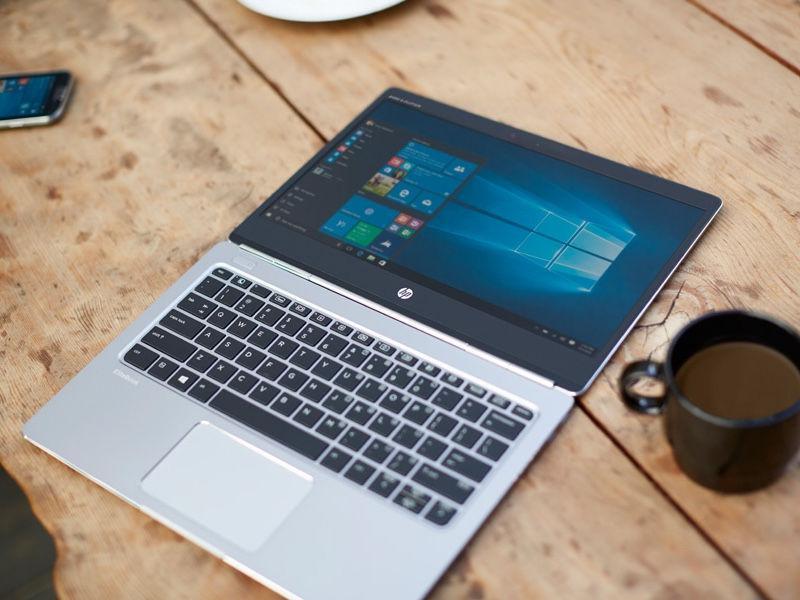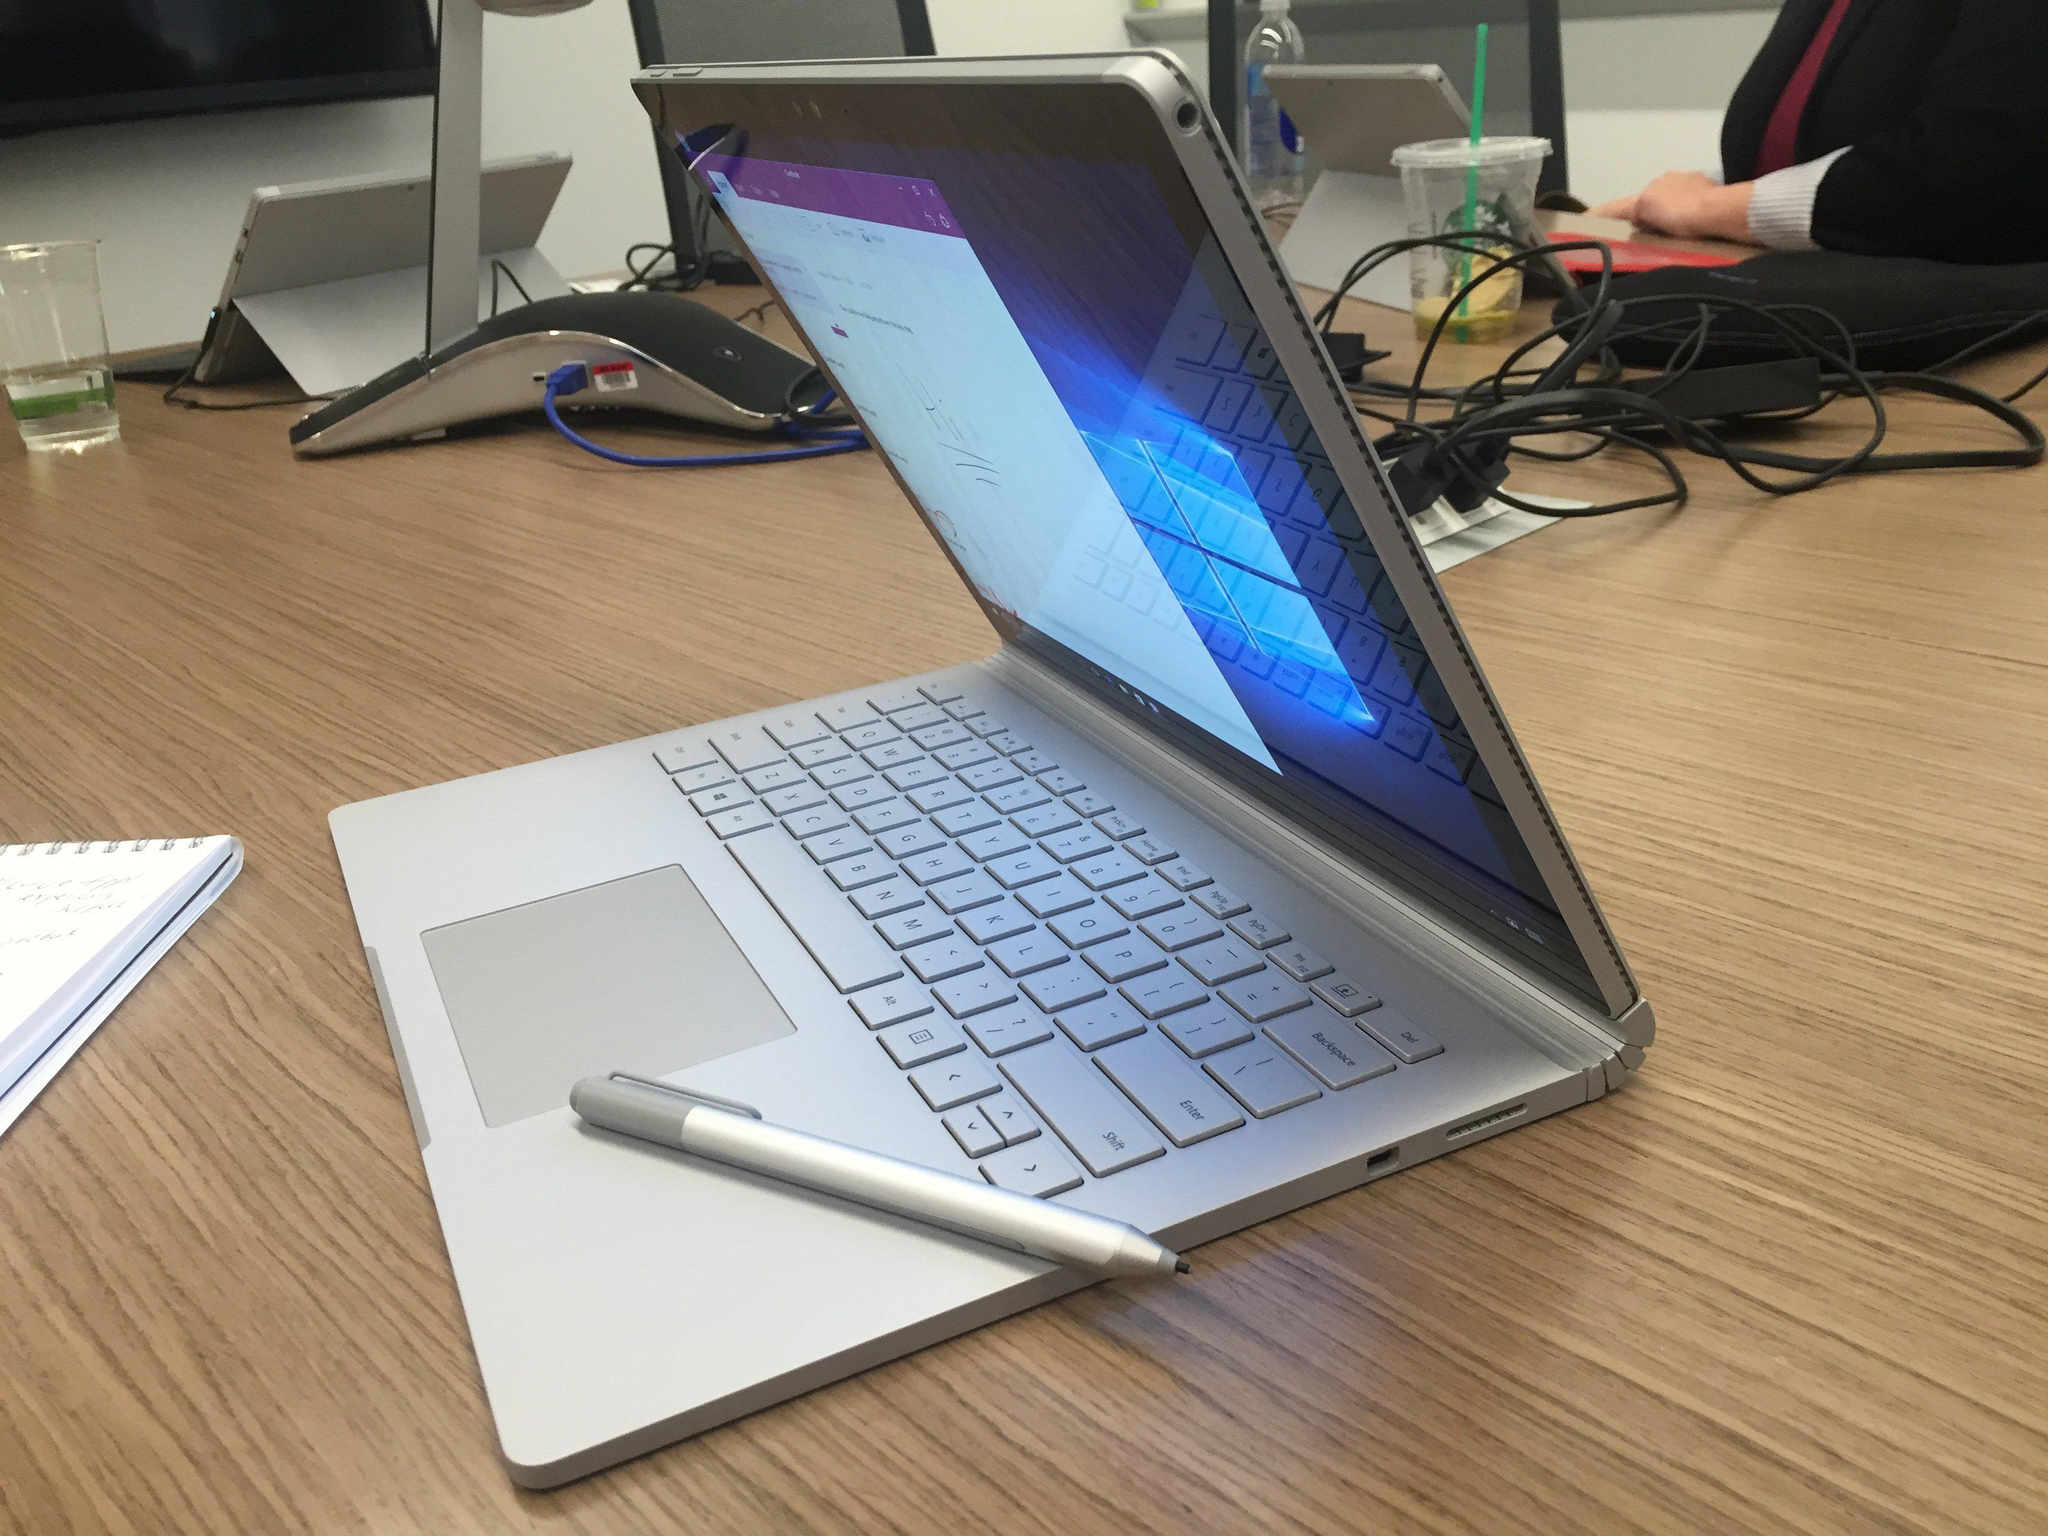The first image is the image on the left, the second image is the image on the right. For the images shown, is this caption "At least one image contains two open laptops, and the left image includes a laptop with a peacock displayed on its screen." true? Answer yes or no. No. The first image is the image on the left, the second image is the image on the right. For the images shown, is this caption "There are two computers" true? Answer yes or no. Yes. 